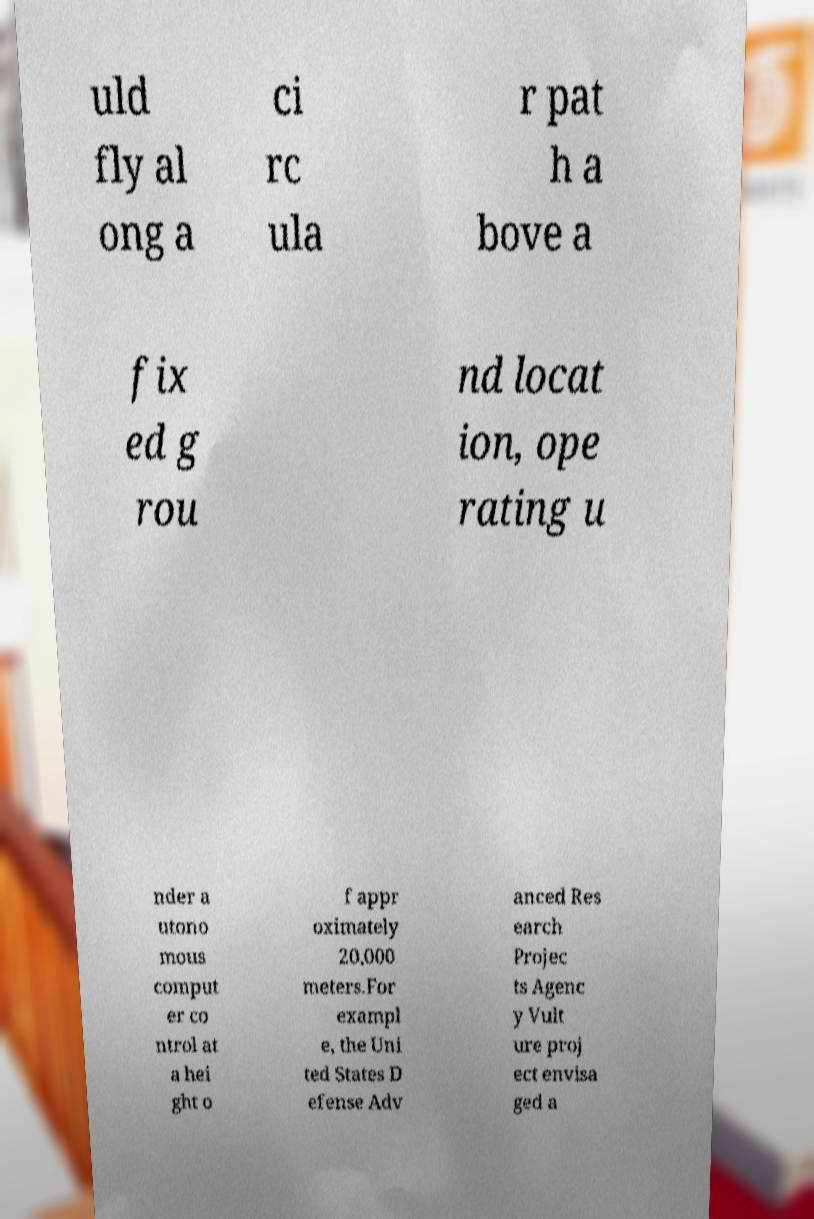Please identify and transcribe the text found in this image. uld fly al ong a ci rc ula r pat h a bove a fix ed g rou nd locat ion, ope rating u nder a utono mous comput er co ntrol at a hei ght o f appr oximately 20,000 meters.For exampl e, the Uni ted States D efense Adv anced Res earch Projec ts Agenc y Vult ure proj ect envisa ged a 